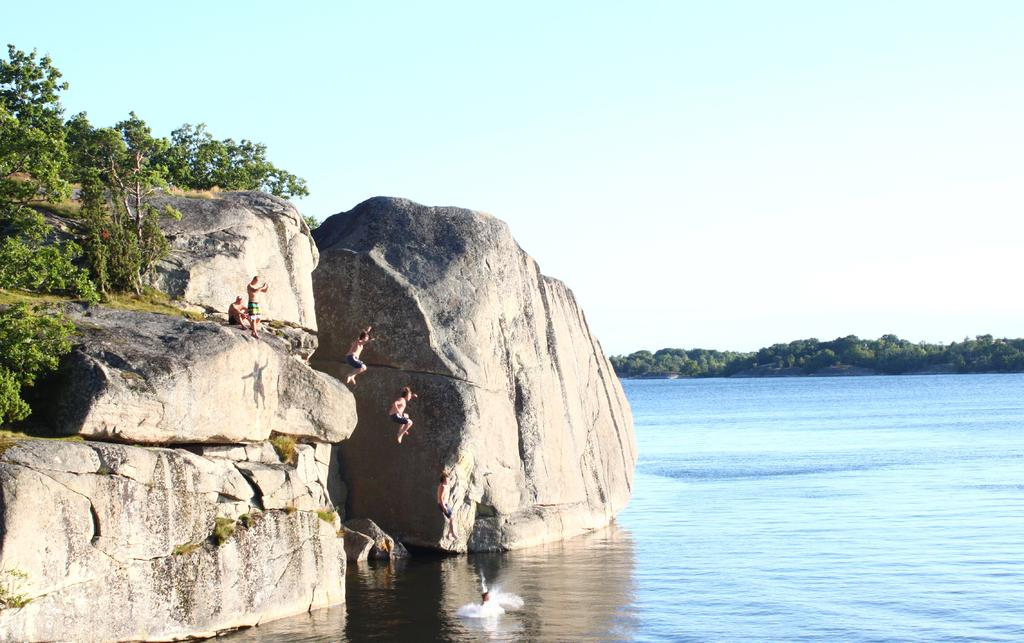How many persons are on the rock in the image? There are two persons on a rock in the image. What are the people doing in the image? People are jumping into the water in the image. What type of natural features can be seen in the image? Rocks, trees, grass, and the sky are visible in the image. What famous writer can be seen sitting on the rock in the image? There is no writer present in the image; it features two persons on a rock. What is the top-rated activity in the image? The image does not provide any information about the top-rated activity; it shows people jumping into the water and two persons on a rock. 